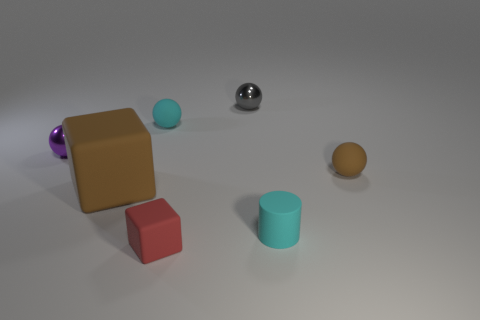Subtract all small cyan rubber spheres. How many spheres are left? 3 Add 3 gray metallic things. How many objects exist? 10 Subtract all brown spheres. How many spheres are left? 3 Subtract all cylinders. How many objects are left? 6 Subtract 3 spheres. How many spheres are left? 1 Subtract all big red cylinders. Subtract all cyan cylinders. How many objects are left? 6 Add 5 cyan cylinders. How many cyan cylinders are left? 6 Add 6 red rubber objects. How many red rubber objects exist? 7 Subtract 0 yellow blocks. How many objects are left? 7 Subtract all blue cylinders. Subtract all purple spheres. How many cylinders are left? 1 